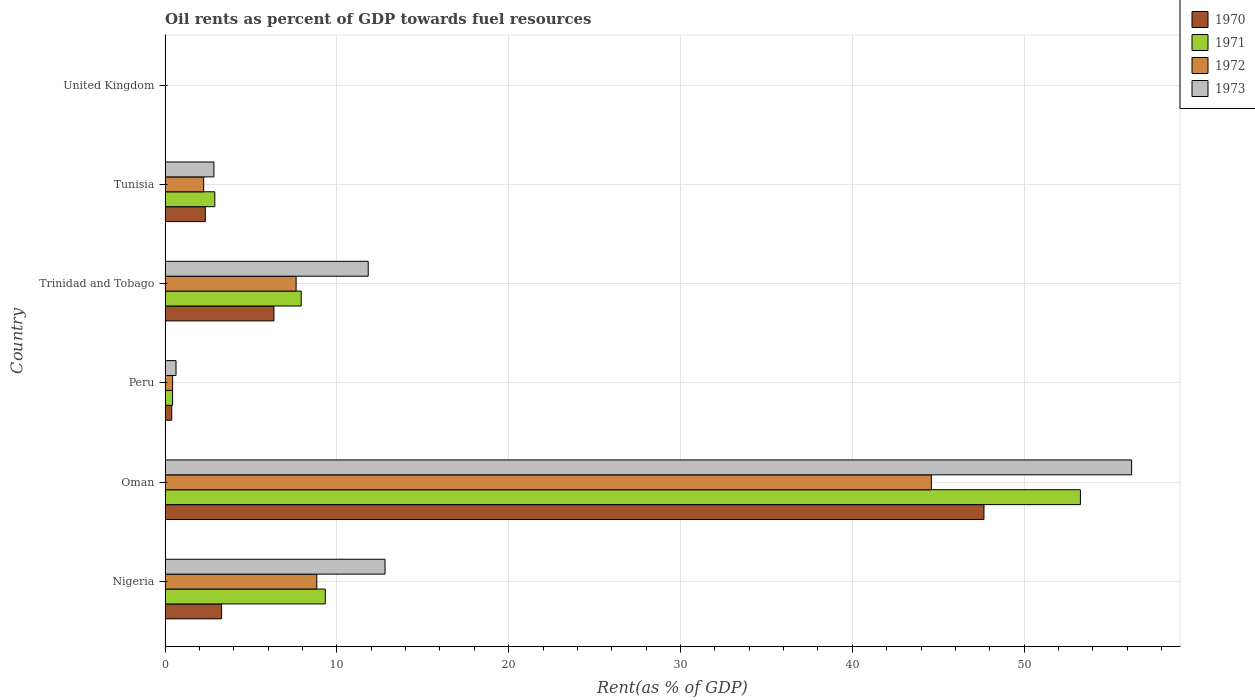How many different coloured bars are there?
Keep it short and to the point. 4. Are the number of bars per tick equal to the number of legend labels?
Offer a terse response. Yes. How many bars are there on the 3rd tick from the bottom?
Offer a terse response. 4. In how many cases, is the number of bars for a given country not equal to the number of legend labels?
Provide a short and direct response. 0. What is the oil rent in 1973 in Tunisia?
Give a very brief answer. 2.84. Across all countries, what is the maximum oil rent in 1972?
Your answer should be compact. 44.6. Across all countries, what is the minimum oil rent in 1972?
Provide a succinct answer. 0. In which country was the oil rent in 1972 maximum?
Provide a short and direct response. Oman. What is the total oil rent in 1970 in the graph?
Offer a terse response. 60.01. What is the difference between the oil rent in 1973 in Nigeria and that in Tunisia?
Provide a succinct answer. 9.96. What is the difference between the oil rent in 1972 in Oman and the oil rent in 1971 in Peru?
Give a very brief answer. 44.16. What is the average oil rent in 1972 per country?
Your response must be concise. 10.62. What is the difference between the oil rent in 1972 and oil rent in 1971 in Peru?
Give a very brief answer. 0. In how many countries, is the oil rent in 1971 greater than 48 %?
Ensure brevity in your answer.  1. What is the ratio of the oil rent in 1972 in Nigeria to that in Tunisia?
Provide a short and direct response. 3.93. Is the difference between the oil rent in 1972 in Nigeria and Peru greater than the difference between the oil rent in 1971 in Nigeria and Peru?
Provide a short and direct response. No. What is the difference between the highest and the second highest oil rent in 1970?
Give a very brief answer. 41.33. What is the difference between the highest and the lowest oil rent in 1972?
Offer a terse response. 44.6. In how many countries, is the oil rent in 1970 greater than the average oil rent in 1970 taken over all countries?
Keep it short and to the point. 1. Is the sum of the oil rent in 1972 in Trinidad and Tobago and United Kingdom greater than the maximum oil rent in 1973 across all countries?
Your answer should be very brief. No. What does the 1st bar from the bottom in Nigeria represents?
Offer a very short reply. 1970. Is it the case that in every country, the sum of the oil rent in 1972 and oil rent in 1973 is greater than the oil rent in 1970?
Keep it short and to the point. Yes. How many bars are there?
Offer a terse response. 24. Are all the bars in the graph horizontal?
Provide a short and direct response. Yes. What is the difference between two consecutive major ticks on the X-axis?
Offer a terse response. 10. Are the values on the major ticks of X-axis written in scientific E-notation?
Provide a short and direct response. No. Where does the legend appear in the graph?
Make the answer very short. Top right. How are the legend labels stacked?
Your response must be concise. Vertical. What is the title of the graph?
Your answer should be very brief. Oil rents as percent of GDP towards fuel resources. Does "2013" appear as one of the legend labels in the graph?
Ensure brevity in your answer.  No. What is the label or title of the X-axis?
Offer a very short reply. Rent(as % of GDP). What is the Rent(as % of GDP) in 1970 in Nigeria?
Make the answer very short. 3.29. What is the Rent(as % of GDP) of 1971 in Nigeria?
Give a very brief answer. 9.32. What is the Rent(as % of GDP) in 1972 in Nigeria?
Your answer should be very brief. 8.83. What is the Rent(as % of GDP) of 1973 in Nigeria?
Keep it short and to the point. 12.8. What is the Rent(as % of GDP) of 1970 in Oman?
Your answer should be very brief. 47.66. What is the Rent(as % of GDP) in 1971 in Oman?
Ensure brevity in your answer.  53.28. What is the Rent(as % of GDP) of 1972 in Oman?
Your answer should be very brief. 44.6. What is the Rent(as % of GDP) in 1973 in Oman?
Make the answer very short. 56.26. What is the Rent(as % of GDP) in 1970 in Peru?
Keep it short and to the point. 0.39. What is the Rent(as % of GDP) of 1971 in Peru?
Make the answer very short. 0.44. What is the Rent(as % of GDP) of 1972 in Peru?
Keep it short and to the point. 0.44. What is the Rent(as % of GDP) of 1973 in Peru?
Ensure brevity in your answer.  0.64. What is the Rent(as % of GDP) of 1970 in Trinidad and Tobago?
Give a very brief answer. 6.33. What is the Rent(as % of GDP) of 1971 in Trinidad and Tobago?
Provide a short and direct response. 7.92. What is the Rent(as % of GDP) in 1972 in Trinidad and Tobago?
Make the answer very short. 7.63. What is the Rent(as % of GDP) of 1973 in Trinidad and Tobago?
Give a very brief answer. 11.82. What is the Rent(as % of GDP) of 1970 in Tunisia?
Your answer should be compact. 2.34. What is the Rent(as % of GDP) in 1971 in Tunisia?
Your answer should be compact. 2.89. What is the Rent(as % of GDP) of 1972 in Tunisia?
Offer a terse response. 2.25. What is the Rent(as % of GDP) in 1973 in Tunisia?
Offer a very short reply. 2.84. What is the Rent(as % of GDP) in 1970 in United Kingdom?
Offer a terse response. 0. What is the Rent(as % of GDP) of 1971 in United Kingdom?
Keep it short and to the point. 0. What is the Rent(as % of GDP) in 1972 in United Kingdom?
Make the answer very short. 0. What is the Rent(as % of GDP) in 1973 in United Kingdom?
Make the answer very short. 0. Across all countries, what is the maximum Rent(as % of GDP) in 1970?
Ensure brevity in your answer.  47.66. Across all countries, what is the maximum Rent(as % of GDP) of 1971?
Make the answer very short. 53.28. Across all countries, what is the maximum Rent(as % of GDP) in 1972?
Your answer should be compact. 44.6. Across all countries, what is the maximum Rent(as % of GDP) of 1973?
Give a very brief answer. 56.26. Across all countries, what is the minimum Rent(as % of GDP) of 1970?
Provide a succinct answer. 0. Across all countries, what is the minimum Rent(as % of GDP) of 1971?
Your answer should be very brief. 0. Across all countries, what is the minimum Rent(as % of GDP) in 1972?
Your answer should be very brief. 0. Across all countries, what is the minimum Rent(as % of GDP) of 1973?
Your answer should be compact. 0. What is the total Rent(as % of GDP) in 1970 in the graph?
Keep it short and to the point. 60.01. What is the total Rent(as % of GDP) of 1971 in the graph?
Provide a short and direct response. 73.85. What is the total Rent(as % of GDP) in 1972 in the graph?
Provide a short and direct response. 63.74. What is the total Rent(as % of GDP) of 1973 in the graph?
Give a very brief answer. 84.36. What is the difference between the Rent(as % of GDP) in 1970 in Nigeria and that in Oman?
Your response must be concise. -44.37. What is the difference between the Rent(as % of GDP) of 1971 in Nigeria and that in Oman?
Ensure brevity in your answer.  -43.95. What is the difference between the Rent(as % of GDP) in 1972 in Nigeria and that in Oman?
Make the answer very short. -35.77. What is the difference between the Rent(as % of GDP) of 1973 in Nigeria and that in Oman?
Provide a succinct answer. -43.46. What is the difference between the Rent(as % of GDP) in 1970 in Nigeria and that in Peru?
Your answer should be compact. 2.9. What is the difference between the Rent(as % of GDP) in 1971 in Nigeria and that in Peru?
Your answer should be compact. 8.89. What is the difference between the Rent(as % of GDP) of 1972 in Nigeria and that in Peru?
Your answer should be compact. 8.39. What is the difference between the Rent(as % of GDP) of 1973 in Nigeria and that in Peru?
Your answer should be compact. 12.16. What is the difference between the Rent(as % of GDP) in 1970 in Nigeria and that in Trinidad and Tobago?
Offer a very short reply. -3.04. What is the difference between the Rent(as % of GDP) of 1971 in Nigeria and that in Trinidad and Tobago?
Your response must be concise. 1.4. What is the difference between the Rent(as % of GDP) of 1972 in Nigeria and that in Trinidad and Tobago?
Offer a terse response. 1.2. What is the difference between the Rent(as % of GDP) of 1973 in Nigeria and that in Trinidad and Tobago?
Offer a very short reply. 0.98. What is the difference between the Rent(as % of GDP) in 1970 in Nigeria and that in Tunisia?
Offer a terse response. 0.95. What is the difference between the Rent(as % of GDP) in 1971 in Nigeria and that in Tunisia?
Keep it short and to the point. 6.43. What is the difference between the Rent(as % of GDP) of 1972 in Nigeria and that in Tunisia?
Provide a succinct answer. 6.58. What is the difference between the Rent(as % of GDP) of 1973 in Nigeria and that in Tunisia?
Your answer should be compact. 9.96. What is the difference between the Rent(as % of GDP) in 1970 in Nigeria and that in United Kingdom?
Provide a succinct answer. 3.29. What is the difference between the Rent(as % of GDP) of 1971 in Nigeria and that in United Kingdom?
Provide a short and direct response. 9.32. What is the difference between the Rent(as % of GDP) in 1972 in Nigeria and that in United Kingdom?
Ensure brevity in your answer.  8.83. What is the difference between the Rent(as % of GDP) of 1973 in Nigeria and that in United Kingdom?
Provide a succinct answer. 12.8. What is the difference between the Rent(as % of GDP) of 1970 in Oman and that in Peru?
Your answer should be compact. 47.28. What is the difference between the Rent(as % of GDP) of 1971 in Oman and that in Peru?
Ensure brevity in your answer.  52.84. What is the difference between the Rent(as % of GDP) in 1972 in Oman and that in Peru?
Your answer should be compact. 44.16. What is the difference between the Rent(as % of GDP) of 1973 in Oman and that in Peru?
Your answer should be compact. 55.62. What is the difference between the Rent(as % of GDP) of 1970 in Oman and that in Trinidad and Tobago?
Your response must be concise. 41.33. What is the difference between the Rent(as % of GDP) in 1971 in Oman and that in Trinidad and Tobago?
Ensure brevity in your answer.  45.35. What is the difference between the Rent(as % of GDP) in 1972 in Oman and that in Trinidad and Tobago?
Give a very brief answer. 36.97. What is the difference between the Rent(as % of GDP) of 1973 in Oman and that in Trinidad and Tobago?
Offer a very short reply. 44.44. What is the difference between the Rent(as % of GDP) in 1970 in Oman and that in Tunisia?
Provide a succinct answer. 45.32. What is the difference between the Rent(as % of GDP) of 1971 in Oman and that in Tunisia?
Give a very brief answer. 50.38. What is the difference between the Rent(as % of GDP) of 1972 in Oman and that in Tunisia?
Keep it short and to the point. 42.36. What is the difference between the Rent(as % of GDP) in 1973 in Oman and that in Tunisia?
Your response must be concise. 53.42. What is the difference between the Rent(as % of GDP) of 1970 in Oman and that in United Kingdom?
Your answer should be very brief. 47.66. What is the difference between the Rent(as % of GDP) of 1971 in Oman and that in United Kingdom?
Keep it short and to the point. 53.28. What is the difference between the Rent(as % of GDP) of 1972 in Oman and that in United Kingdom?
Offer a very short reply. 44.6. What is the difference between the Rent(as % of GDP) in 1973 in Oman and that in United Kingdom?
Provide a succinct answer. 56.26. What is the difference between the Rent(as % of GDP) in 1970 in Peru and that in Trinidad and Tobago?
Make the answer very short. -5.95. What is the difference between the Rent(as % of GDP) in 1971 in Peru and that in Trinidad and Tobago?
Offer a terse response. -7.49. What is the difference between the Rent(as % of GDP) of 1972 in Peru and that in Trinidad and Tobago?
Your response must be concise. -7.19. What is the difference between the Rent(as % of GDP) of 1973 in Peru and that in Trinidad and Tobago?
Your answer should be compact. -11.19. What is the difference between the Rent(as % of GDP) of 1970 in Peru and that in Tunisia?
Your response must be concise. -1.95. What is the difference between the Rent(as % of GDP) in 1971 in Peru and that in Tunisia?
Offer a very short reply. -2.46. What is the difference between the Rent(as % of GDP) in 1972 in Peru and that in Tunisia?
Give a very brief answer. -1.81. What is the difference between the Rent(as % of GDP) of 1973 in Peru and that in Tunisia?
Offer a very short reply. -2.21. What is the difference between the Rent(as % of GDP) in 1970 in Peru and that in United Kingdom?
Offer a terse response. 0.38. What is the difference between the Rent(as % of GDP) of 1971 in Peru and that in United Kingdom?
Offer a terse response. 0.44. What is the difference between the Rent(as % of GDP) in 1972 in Peru and that in United Kingdom?
Your answer should be compact. 0.44. What is the difference between the Rent(as % of GDP) of 1973 in Peru and that in United Kingdom?
Offer a terse response. 0.63. What is the difference between the Rent(as % of GDP) of 1970 in Trinidad and Tobago and that in Tunisia?
Ensure brevity in your answer.  3.99. What is the difference between the Rent(as % of GDP) of 1971 in Trinidad and Tobago and that in Tunisia?
Keep it short and to the point. 5.03. What is the difference between the Rent(as % of GDP) of 1972 in Trinidad and Tobago and that in Tunisia?
Your response must be concise. 5.38. What is the difference between the Rent(as % of GDP) of 1973 in Trinidad and Tobago and that in Tunisia?
Keep it short and to the point. 8.98. What is the difference between the Rent(as % of GDP) in 1970 in Trinidad and Tobago and that in United Kingdom?
Offer a terse response. 6.33. What is the difference between the Rent(as % of GDP) of 1971 in Trinidad and Tobago and that in United Kingdom?
Your answer should be very brief. 7.92. What is the difference between the Rent(as % of GDP) of 1972 in Trinidad and Tobago and that in United Kingdom?
Make the answer very short. 7.62. What is the difference between the Rent(as % of GDP) in 1973 in Trinidad and Tobago and that in United Kingdom?
Give a very brief answer. 11.82. What is the difference between the Rent(as % of GDP) in 1970 in Tunisia and that in United Kingdom?
Keep it short and to the point. 2.34. What is the difference between the Rent(as % of GDP) of 1971 in Tunisia and that in United Kingdom?
Offer a terse response. 2.89. What is the difference between the Rent(as % of GDP) in 1972 in Tunisia and that in United Kingdom?
Your answer should be very brief. 2.24. What is the difference between the Rent(as % of GDP) in 1973 in Tunisia and that in United Kingdom?
Offer a terse response. 2.84. What is the difference between the Rent(as % of GDP) of 1970 in Nigeria and the Rent(as % of GDP) of 1971 in Oman?
Offer a terse response. -49.99. What is the difference between the Rent(as % of GDP) of 1970 in Nigeria and the Rent(as % of GDP) of 1972 in Oman?
Ensure brevity in your answer.  -41.31. What is the difference between the Rent(as % of GDP) of 1970 in Nigeria and the Rent(as % of GDP) of 1973 in Oman?
Ensure brevity in your answer.  -52.97. What is the difference between the Rent(as % of GDP) of 1971 in Nigeria and the Rent(as % of GDP) of 1972 in Oman?
Make the answer very short. -35.28. What is the difference between the Rent(as % of GDP) in 1971 in Nigeria and the Rent(as % of GDP) in 1973 in Oman?
Offer a very short reply. -46.94. What is the difference between the Rent(as % of GDP) in 1972 in Nigeria and the Rent(as % of GDP) in 1973 in Oman?
Your answer should be very brief. -47.43. What is the difference between the Rent(as % of GDP) of 1970 in Nigeria and the Rent(as % of GDP) of 1971 in Peru?
Your answer should be very brief. 2.85. What is the difference between the Rent(as % of GDP) of 1970 in Nigeria and the Rent(as % of GDP) of 1972 in Peru?
Provide a short and direct response. 2.85. What is the difference between the Rent(as % of GDP) of 1970 in Nigeria and the Rent(as % of GDP) of 1973 in Peru?
Your response must be concise. 2.65. What is the difference between the Rent(as % of GDP) of 1971 in Nigeria and the Rent(as % of GDP) of 1972 in Peru?
Offer a very short reply. 8.88. What is the difference between the Rent(as % of GDP) of 1971 in Nigeria and the Rent(as % of GDP) of 1973 in Peru?
Your response must be concise. 8.69. What is the difference between the Rent(as % of GDP) of 1972 in Nigeria and the Rent(as % of GDP) of 1973 in Peru?
Offer a terse response. 8.19. What is the difference between the Rent(as % of GDP) in 1970 in Nigeria and the Rent(as % of GDP) in 1971 in Trinidad and Tobago?
Provide a succinct answer. -4.63. What is the difference between the Rent(as % of GDP) of 1970 in Nigeria and the Rent(as % of GDP) of 1972 in Trinidad and Tobago?
Give a very brief answer. -4.34. What is the difference between the Rent(as % of GDP) in 1970 in Nigeria and the Rent(as % of GDP) in 1973 in Trinidad and Tobago?
Ensure brevity in your answer.  -8.53. What is the difference between the Rent(as % of GDP) of 1971 in Nigeria and the Rent(as % of GDP) of 1972 in Trinidad and Tobago?
Give a very brief answer. 1.7. What is the difference between the Rent(as % of GDP) of 1971 in Nigeria and the Rent(as % of GDP) of 1973 in Trinidad and Tobago?
Your response must be concise. -2.5. What is the difference between the Rent(as % of GDP) in 1972 in Nigeria and the Rent(as % of GDP) in 1973 in Trinidad and Tobago?
Keep it short and to the point. -2.99. What is the difference between the Rent(as % of GDP) in 1970 in Nigeria and the Rent(as % of GDP) in 1971 in Tunisia?
Your answer should be compact. 0.4. What is the difference between the Rent(as % of GDP) of 1970 in Nigeria and the Rent(as % of GDP) of 1972 in Tunisia?
Your response must be concise. 1.04. What is the difference between the Rent(as % of GDP) of 1970 in Nigeria and the Rent(as % of GDP) of 1973 in Tunisia?
Your answer should be compact. 0.45. What is the difference between the Rent(as % of GDP) in 1971 in Nigeria and the Rent(as % of GDP) in 1972 in Tunisia?
Your answer should be compact. 7.08. What is the difference between the Rent(as % of GDP) in 1971 in Nigeria and the Rent(as % of GDP) in 1973 in Tunisia?
Ensure brevity in your answer.  6.48. What is the difference between the Rent(as % of GDP) of 1972 in Nigeria and the Rent(as % of GDP) of 1973 in Tunisia?
Your response must be concise. 5.99. What is the difference between the Rent(as % of GDP) of 1970 in Nigeria and the Rent(as % of GDP) of 1971 in United Kingdom?
Your response must be concise. 3.29. What is the difference between the Rent(as % of GDP) of 1970 in Nigeria and the Rent(as % of GDP) of 1972 in United Kingdom?
Your response must be concise. 3.29. What is the difference between the Rent(as % of GDP) in 1970 in Nigeria and the Rent(as % of GDP) in 1973 in United Kingdom?
Keep it short and to the point. 3.29. What is the difference between the Rent(as % of GDP) in 1971 in Nigeria and the Rent(as % of GDP) in 1972 in United Kingdom?
Provide a succinct answer. 9.32. What is the difference between the Rent(as % of GDP) of 1971 in Nigeria and the Rent(as % of GDP) of 1973 in United Kingdom?
Your answer should be compact. 9.32. What is the difference between the Rent(as % of GDP) of 1972 in Nigeria and the Rent(as % of GDP) of 1973 in United Kingdom?
Your answer should be compact. 8.83. What is the difference between the Rent(as % of GDP) of 1970 in Oman and the Rent(as % of GDP) of 1971 in Peru?
Give a very brief answer. 47.23. What is the difference between the Rent(as % of GDP) of 1970 in Oman and the Rent(as % of GDP) of 1972 in Peru?
Your answer should be compact. 47.22. What is the difference between the Rent(as % of GDP) in 1970 in Oman and the Rent(as % of GDP) in 1973 in Peru?
Your answer should be compact. 47.03. What is the difference between the Rent(as % of GDP) in 1971 in Oman and the Rent(as % of GDP) in 1972 in Peru?
Offer a very short reply. 52.84. What is the difference between the Rent(as % of GDP) in 1971 in Oman and the Rent(as % of GDP) in 1973 in Peru?
Your response must be concise. 52.64. What is the difference between the Rent(as % of GDP) in 1972 in Oman and the Rent(as % of GDP) in 1973 in Peru?
Provide a succinct answer. 43.96. What is the difference between the Rent(as % of GDP) in 1970 in Oman and the Rent(as % of GDP) in 1971 in Trinidad and Tobago?
Your answer should be compact. 39.74. What is the difference between the Rent(as % of GDP) in 1970 in Oman and the Rent(as % of GDP) in 1972 in Trinidad and Tobago?
Offer a very short reply. 40.04. What is the difference between the Rent(as % of GDP) in 1970 in Oman and the Rent(as % of GDP) in 1973 in Trinidad and Tobago?
Keep it short and to the point. 35.84. What is the difference between the Rent(as % of GDP) in 1971 in Oman and the Rent(as % of GDP) in 1972 in Trinidad and Tobago?
Ensure brevity in your answer.  45.65. What is the difference between the Rent(as % of GDP) of 1971 in Oman and the Rent(as % of GDP) of 1973 in Trinidad and Tobago?
Provide a short and direct response. 41.45. What is the difference between the Rent(as % of GDP) of 1972 in Oman and the Rent(as % of GDP) of 1973 in Trinidad and Tobago?
Make the answer very short. 32.78. What is the difference between the Rent(as % of GDP) of 1970 in Oman and the Rent(as % of GDP) of 1971 in Tunisia?
Offer a terse response. 44.77. What is the difference between the Rent(as % of GDP) of 1970 in Oman and the Rent(as % of GDP) of 1972 in Tunisia?
Give a very brief answer. 45.42. What is the difference between the Rent(as % of GDP) in 1970 in Oman and the Rent(as % of GDP) in 1973 in Tunisia?
Your answer should be very brief. 44.82. What is the difference between the Rent(as % of GDP) of 1971 in Oman and the Rent(as % of GDP) of 1972 in Tunisia?
Give a very brief answer. 51.03. What is the difference between the Rent(as % of GDP) of 1971 in Oman and the Rent(as % of GDP) of 1973 in Tunisia?
Provide a short and direct response. 50.43. What is the difference between the Rent(as % of GDP) of 1972 in Oman and the Rent(as % of GDP) of 1973 in Tunisia?
Keep it short and to the point. 41.76. What is the difference between the Rent(as % of GDP) of 1970 in Oman and the Rent(as % of GDP) of 1971 in United Kingdom?
Your answer should be compact. 47.66. What is the difference between the Rent(as % of GDP) in 1970 in Oman and the Rent(as % of GDP) in 1972 in United Kingdom?
Make the answer very short. 47.66. What is the difference between the Rent(as % of GDP) in 1970 in Oman and the Rent(as % of GDP) in 1973 in United Kingdom?
Keep it short and to the point. 47.66. What is the difference between the Rent(as % of GDP) in 1971 in Oman and the Rent(as % of GDP) in 1972 in United Kingdom?
Your response must be concise. 53.28. What is the difference between the Rent(as % of GDP) in 1971 in Oman and the Rent(as % of GDP) in 1973 in United Kingdom?
Keep it short and to the point. 53.27. What is the difference between the Rent(as % of GDP) of 1972 in Oman and the Rent(as % of GDP) of 1973 in United Kingdom?
Ensure brevity in your answer.  44.6. What is the difference between the Rent(as % of GDP) of 1970 in Peru and the Rent(as % of GDP) of 1971 in Trinidad and Tobago?
Provide a succinct answer. -7.54. What is the difference between the Rent(as % of GDP) in 1970 in Peru and the Rent(as % of GDP) in 1972 in Trinidad and Tobago?
Offer a very short reply. -7.24. What is the difference between the Rent(as % of GDP) in 1970 in Peru and the Rent(as % of GDP) in 1973 in Trinidad and Tobago?
Keep it short and to the point. -11.44. What is the difference between the Rent(as % of GDP) of 1971 in Peru and the Rent(as % of GDP) of 1972 in Trinidad and Tobago?
Your response must be concise. -7.19. What is the difference between the Rent(as % of GDP) of 1971 in Peru and the Rent(as % of GDP) of 1973 in Trinidad and Tobago?
Your answer should be compact. -11.39. What is the difference between the Rent(as % of GDP) in 1972 in Peru and the Rent(as % of GDP) in 1973 in Trinidad and Tobago?
Offer a very short reply. -11.38. What is the difference between the Rent(as % of GDP) of 1970 in Peru and the Rent(as % of GDP) of 1971 in Tunisia?
Give a very brief answer. -2.51. What is the difference between the Rent(as % of GDP) of 1970 in Peru and the Rent(as % of GDP) of 1972 in Tunisia?
Provide a succinct answer. -1.86. What is the difference between the Rent(as % of GDP) of 1970 in Peru and the Rent(as % of GDP) of 1973 in Tunisia?
Offer a very short reply. -2.46. What is the difference between the Rent(as % of GDP) in 1971 in Peru and the Rent(as % of GDP) in 1972 in Tunisia?
Your answer should be very brief. -1.81. What is the difference between the Rent(as % of GDP) in 1971 in Peru and the Rent(as % of GDP) in 1973 in Tunisia?
Make the answer very short. -2.4. What is the difference between the Rent(as % of GDP) in 1972 in Peru and the Rent(as % of GDP) in 1973 in Tunisia?
Offer a very short reply. -2.4. What is the difference between the Rent(as % of GDP) in 1970 in Peru and the Rent(as % of GDP) in 1971 in United Kingdom?
Ensure brevity in your answer.  0.38. What is the difference between the Rent(as % of GDP) in 1970 in Peru and the Rent(as % of GDP) in 1972 in United Kingdom?
Your response must be concise. 0.38. What is the difference between the Rent(as % of GDP) of 1970 in Peru and the Rent(as % of GDP) of 1973 in United Kingdom?
Your answer should be compact. 0.38. What is the difference between the Rent(as % of GDP) of 1971 in Peru and the Rent(as % of GDP) of 1972 in United Kingdom?
Provide a succinct answer. 0.44. What is the difference between the Rent(as % of GDP) in 1971 in Peru and the Rent(as % of GDP) in 1973 in United Kingdom?
Make the answer very short. 0.43. What is the difference between the Rent(as % of GDP) in 1972 in Peru and the Rent(as % of GDP) in 1973 in United Kingdom?
Your answer should be compact. 0.44. What is the difference between the Rent(as % of GDP) in 1970 in Trinidad and Tobago and the Rent(as % of GDP) in 1971 in Tunisia?
Offer a very short reply. 3.44. What is the difference between the Rent(as % of GDP) of 1970 in Trinidad and Tobago and the Rent(as % of GDP) of 1972 in Tunisia?
Offer a terse response. 4.09. What is the difference between the Rent(as % of GDP) of 1970 in Trinidad and Tobago and the Rent(as % of GDP) of 1973 in Tunisia?
Keep it short and to the point. 3.49. What is the difference between the Rent(as % of GDP) of 1971 in Trinidad and Tobago and the Rent(as % of GDP) of 1972 in Tunisia?
Offer a terse response. 5.68. What is the difference between the Rent(as % of GDP) of 1971 in Trinidad and Tobago and the Rent(as % of GDP) of 1973 in Tunisia?
Offer a very short reply. 5.08. What is the difference between the Rent(as % of GDP) in 1972 in Trinidad and Tobago and the Rent(as % of GDP) in 1973 in Tunisia?
Your response must be concise. 4.78. What is the difference between the Rent(as % of GDP) in 1970 in Trinidad and Tobago and the Rent(as % of GDP) in 1971 in United Kingdom?
Your answer should be very brief. 6.33. What is the difference between the Rent(as % of GDP) of 1970 in Trinidad and Tobago and the Rent(as % of GDP) of 1972 in United Kingdom?
Your answer should be very brief. 6.33. What is the difference between the Rent(as % of GDP) of 1970 in Trinidad and Tobago and the Rent(as % of GDP) of 1973 in United Kingdom?
Offer a very short reply. 6.33. What is the difference between the Rent(as % of GDP) in 1971 in Trinidad and Tobago and the Rent(as % of GDP) in 1972 in United Kingdom?
Provide a short and direct response. 7.92. What is the difference between the Rent(as % of GDP) of 1971 in Trinidad and Tobago and the Rent(as % of GDP) of 1973 in United Kingdom?
Make the answer very short. 7.92. What is the difference between the Rent(as % of GDP) in 1972 in Trinidad and Tobago and the Rent(as % of GDP) in 1973 in United Kingdom?
Make the answer very short. 7.62. What is the difference between the Rent(as % of GDP) in 1970 in Tunisia and the Rent(as % of GDP) in 1971 in United Kingdom?
Make the answer very short. 2.34. What is the difference between the Rent(as % of GDP) of 1970 in Tunisia and the Rent(as % of GDP) of 1972 in United Kingdom?
Provide a succinct answer. 2.34. What is the difference between the Rent(as % of GDP) in 1970 in Tunisia and the Rent(as % of GDP) in 1973 in United Kingdom?
Your answer should be very brief. 2.34. What is the difference between the Rent(as % of GDP) in 1971 in Tunisia and the Rent(as % of GDP) in 1972 in United Kingdom?
Your answer should be compact. 2.89. What is the difference between the Rent(as % of GDP) of 1971 in Tunisia and the Rent(as % of GDP) of 1973 in United Kingdom?
Your answer should be very brief. 2.89. What is the difference between the Rent(as % of GDP) in 1972 in Tunisia and the Rent(as % of GDP) in 1973 in United Kingdom?
Provide a short and direct response. 2.24. What is the average Rent(as % of GDP) in 1970 per country?
Provide a succinct answer. 10. What is the average Rent(as % of GDP) in 1971 per country?
Offer a terse response. 12.31. What is the average Rent(as % of GDP) in 1972 per country?
Offer a very short reply. 10.62. What is the average Rent(as % of GDP) of 1973 per country?
Your answer should be compact. 14.06. What is the difference between the Rent(as % of GDP) in 1970 and Rent(as % of GDP) in 1971 in Nigeria?
Give a very brief answer. -6.03. What is the difference between the Rent(as % of GDP) in 1970 and Rent(as % of GDP) in 1972 in Nigeria?
Your answer should be very brief. -5.54. What is the difference between the Rent(as % of GDP) of 1970 and Rent(as % of GDP) of 1973 in Nigeria?
Offer a terse response. -9.51. What is the difference between the Rent(as % of GDP) in 1971 and Rent(as % of GDP) in 1972 in Nigeria?
Ensure brevity in your answer.  0.49. What is the difference between the Rent(as % of GDP) of 1971 and Rent(as % of GDP) of 1973 in Nigeria?
Your answer should be compact. -3.48. What is the difference between the Rent(as % of GDP) of 1972 and Rent(as % of GDP) of 1973 in Nigeria?
Provide a succinct answer. -3.97. What is the difference between the Rent(as % of GDP) of 1970 and Rent(as % of GDP) of 1971 in Oman?
Keep it short and to the point. -5.61. What is the difference between the Rent(as % of GDP) of 1970 and Rent(as % of GDP) of 1972 in Oman?
Provide a succinct answer. 3.06. What is the difference between the Rent(as % of GDP) in 1970 and Rent(as % of GDP) in 1973 in Oman?
Provide a short and direct response. -8.6. What is the difference between the Rent(as % of GDP) of 1971 and Rent(as % of GDP) of 1972 in Oman?
Offer a terse response. 8.68. What is the difference between the Rent(as % of GDP) of 1971 and Rent(as % of GDP) of 1973 in Oman?
Provide a short and direct response. -2.98. What is the difference between the Rent(as % of GDP) in 1972 and Rent(as % of GDP) in 1973 in Oman?
Provide a succinct answer. -11.66. What is the difference between the Rent(as % of GDP) in 1970 and Rent(as % of GDP) in 1971 in Peru?
Give a very brief answer. -0.05. What is the difference between the Rent(as % of GDP) in 1970 and Rent(as % of GDP) in 1972 in Peru?
Your answer should be compact. -0.05. What is the difference between the Rent(as % of GDP) of 1970 and Rent(as % of GDP) of 1973 in Peru?
Give a very brief answer. -0.25. What is the difference between the Rent(as % of GDP) of 1971 and Rent(as % of GDP) of 1972 in Peru?
Provide a succinct answer. -0. What is the difference between the Rent(as % of GDP) of 1971 and Rent(as % of GDP) of 1973 in Peru?
Keep it short and to the point. -0.2. What is the difference between the Rent(as % of GDP) in 1972 and Rent(as % of GDP) in 1973 in Peru?
Make the answer very short. -0.2. What is the difference between the Rent(as % of GDP) in 1970 and Rent(as % of GDP) in 1971 in Trinidad and Tobago?
Your answer should be very brief. -1.59. What is the difference between the Rent(as % of GDP) of 1970 and Rent(as % of GDP) of 1972 in Trinidad and Tobago?
Ensure brevity in your answer.  -1.29. What is the difference between the Rent(as % of GDP) in 1970 and Rent(as % of GDP) in 1973 in Trinidad and Tobago?
Your answer should be very brief. -5.49. What is the difference between the Rent(as % of GDP) of 1971 and Rent(as % of GDP) of 1972 in Trinidad and Tobago?
Make the answer very short. 0.3. What is the difference between the Rent(as % of GDP) in 1971 and Rent(as % of GDP) in 1973 in Trinidad and Tobago?
Give a very brief answer. -3.9. What is the difference between the Rent(as % of GDP) of 1972 and Rent(as % of GDP) of 1973 in Trinidad and Tobago?
Ensure brevity in your answer.  -4.2. What is the difference between the Rent(as % of GDP) in 1970 and Rent(as % of GDP) in 1971 in Tunisia?
Offer a terse response. -0.55. What is the difference between the Rent(as % of GDP) in 1970 and Rent(as % of GDP) in 1972 in Tunisia?
Offer a terse response. 0.1. What is the difference between the Rent(as % of GDP) of 1970 and Rent(as % of GDP) of 1973 in Tunisia?
Offer a terse response. -0.5. What is the difference between the Rent(as % of GDP) of 1971 and Rent(as % of GDP) of 1972 in Tunisia?
Ensure brevity in your answer.  0.65. What is the difference between the Rent(as % of GDP) of 1971 and Rent(as % of GDP) of 1973 in Tunisia?
Give a very brief answer. 0.05. What is the difference between the Rent(as % of GDP) in 1972 and Rent(as % of GDP) in 1973 in Tunisia?
Your response must be concise. -0.6. What is the difference between the Rent(as % of GDP) in 1970 and Rent(as % of GDP) in 1972 in United Kingdom?
Give a very brief answer. -0. What is the difference between the Rent(as % of GDP) in 1970 and Rent(as % of GDP) in 1973 in United Kingdom?
Give a very brief answer. -0. What is the difference between the Rent(as % of GDP) of 1971 and Rent(as % of GDP) of 1972 in United Kingdom?
Your answer should be compact. -0. What is the difference between the Rent(as % of GDP) in 1971 and Rent(as % of GDP) in 1973 in United Kingdom?
Offer a terse response. -0. What is the difference between the Rent(as % of GDP) of 1972 and Rent(as % of GDP) of 1973 in United Kingdom?
Your answer should be very brief. -0. What is the ratio of the Rent(as % of GDP) of 1970 in Nigeria to that in Oman?
Give a very brief answer. 0.07. What is the ratio of the Rent(as % of GDP) of 1971 in Nigeria to that in Oman?
Make the answer very short. 0.17. What is the ratio of the Rent(as % of GDP) in 1972 in Nigeria to that in Oman?
Provide a short and direct response. 0.2. What is the ratio of the Rent(as % of GDP) of 1973 in Nigeria to that in Oman?
Keep it short and to the point. 0.23. What is the ratio of the Rent(as % of GDP) of 1970 in Nigeria to that in Peru?
Your response must be concise. 8.53. What is the ratio of the Rent(as % of GDP) of 1971 in Nigeria to that in Peru?
Give a very brief answer. 21.35. What is the ratio of the Rent(as % of GDP) of 1972 in Nigeria to that in Peru?
Provide a short and direct response. 20.12. What is the ratio of the Rent(as % of GDP) in 1973 in Nigeria to that in Peru?
Provide a short and direct response. 20.13. What is the ratio of the Rent(as % of GDP) in 1970 in Nigeria to that in Trinidad and Tobago?
Your answer should be compact. 0.52. What is the ratio of the Rent(as % of GDP) in 1971 in Nigeria to that in Trinidad and Tobago?
Keep it short and to the point. 1.18. What is the ratio of the Rent(as % of GDP) in 1972 in Nigeria to that in Trinidad and Tobago?
Give a very brief answer. 1.16. What is the ratio of the Rent(as % of GDP) of 1973 in Nigeria to that in Trinidad and Tobago?
Your answer should be compact. 1.08. What is the ratio of the Rent(as % of GDP) in 1970 in Nigeria to that in Tunisia?
Your response must be concise. 1.41. What is the ratio of the Rent(as % of GDP) in 1971 in Nigeria to that in Tunisia?
Keep it short and to the point. 3.22. What is the ratio of the Rent(as % of GDP) in 1972 in Nigeria to that in Tunisia?
Offer a terse response. 3.93. What is the ratio of the Rent(as % of GDP) in 1973 in Nigeria to that in Tunisia?
Your answer should be very brief. 4.5. What is the ratio of the Rent(as % of GDP) of 1970 in Nigeria to that in United Kingdom?
Give a very brief answer. 3714.35. What is the ratio of the Rent(as % of GDP) in 1971 in Nigeria to that in United Kingdom?
Give a very brief answer. 1.32e+04. What is the ratio of the Rent(as % of GDP) in 1972 in Nigeria to that in United Kingdom?
Keep it short and to the point. 6825.07. What is the ratio of the Rent(as % of GDP) of 1973 in Nigeria to that in United Kingdom?
Ensure brevity in your answer.  5703.97. What is the ratio of the Rent(as % of GDP) of 1970 in Oman to that in Peru?
Provide a short and direct response. 123.65. What is the ratio of the Rent(as % of GDP) of 1971 in Oman to that in Peru?
Keep it short and to the point. 121.98. What is the ratio of the Rent(as % of GDP) in 1972 in Oman to that in Peru?
Ensure brevity in your answer.  101.64. What is the ratio of the Rent(as % of GDP) of 1973 in Oman to that in Peru?
Provide a short and direct response. 88.49. What is the ratio of the Rent(as % of GDP) of 1970 in Oman to that in Trinidad and Tobago?
Your response must be concise. 7.52. What is the ratio of the Rent(as % of GDP) in 1971 in Oman to that in Trinidad and Tobago?
Your response must be concise. 6.73. What is the ratio of the Rent(as % of GDP) in 1972 in Oman to that in Trinidad and Tobago?
Your response must be concise. 5.85. What is the ratio of the Rent(as % of GDP) in 1973 in Oman to that in Trinidad and Tobago?
Provide a succinct answer. 4.76. What is the ratio of the Rent(as % of GDP) in 1970 in Oman to that in Tunisia?
Your answer should be very brief. 20.37. What is the ratio of the Rent(as % of GDP) of 1971 in Oman to that in Tunisia?
Your answer should be very brief. 18.41. What is the ratio of the Rent(as % of GDP) of 1972 in Oman to that in Tunisia?
Your response must be concise. 19.87. What is the ratio of the Rent(as % of GDP) of 1973 in Oman to that in Tunisia?
Provide a short and direct response. 19.8. What is the ratio of the Rent(as % of GDP) in 1970 in Oman to that in United Kingdom?
Make the answer very short. 5.38e+04. What is the ratio of the Rent(as % of GDP) in 1971 in Oman to that in United Kingdom?
Offer a very short reply. 7.53e+04. What is the ratio of the Rent(as % of GDP) in 1972 in Oman to that in United Kingdom?
Your answer should be very brief. 3.45e+04. What is the ratio of the Rent(as % of GDP) in 1973 in Oman to that in United Kingdom?
Provide a succinct answer. 2.51e+04. What is the ratio of the Rent(as % of GDP) in 1970 in Peru to that in Trinidad and Tobago?
Offer a very short reply. 0.06. What is the ratio of the Rent(as % of GDP) in 1971 in Peru to that in Trinidad and Tobago?
Your response must be concise. 0.06. What is the ratio of the Rent(as % of GDP) in 1972 in Peru to that in Trinidad and Tobago?
Ensure brevity in your answer.  0.06. What is the ratio of the Rent(as % of GDP) of 1973 in Peru to that in Trinidad and Tobago?
Provide a short and direct response. 0.05. What is the ratio of the Rent(as % of GDP) in 1970 in Peru to that in Tunisia?
Keep it short and to the point. 0.16. What is the ratio of the Rent(as % of GDP) in 1971 in Peru to that in Tunisia?
Your response must be concise. 0.15. What is the ratio of the Rent(as % of GDP) of 1972 in Peru to that in Tunisia?
Keep it short and to the point. 0.2. What is the ratio of the Rent(as % of GDP) in 1973 in Peru to that in Tunisia?
Your answer should be very brief. 0.22. What is the ratio of the Rent(as % of GDP) of 1970 in Peru to that in United Kingdom?
Provide a succinct answer. 435.22. What is the ratio of the Rent(as % of GDP) in 1971 in Peru to that in United Kingdom?
Offer a very short reply. 617.08. What is the ratio of the Rent(as % of GDP) of 1972 in Peru to that in United Kingdom?
Make the answer very short. 339.21. What is the ratio of the Rent(as % of GDP) in 1973 in Peru to that in United Kingdom?
Your answer should be very brief. 283.34. What is the ratio of the Rent(as % of GDP) in 1970 in Trinidad and Tobago to that in Tunisia?
Your answer should be compact. 2.71. What is the ratio of the Rent(as % of GDP) of 1971 in Trinidad and Tobago to that in Tunisia?
Ensure brevity in your answer.  2.74. What is the ratio of the Rent(as % of GDP) in 1972 in Trinidad and Tobago to that in Tunisia?
Offer a terse response. 3.4. What is the ratio of the Rent(as % of GDP) in 1973 in Trinidad and Tobago to that in Tunisia?
Give a very brief answer. 4.16. What is the ratio of the Rent(as % of GDP) of 1970 in Trinidad and Tobago to that in United Kingdom?
Ensure brevity in your answer.  7151.98. What is the ratio of the Rent(as % of GDP) of 1971 in Trinidad and Tobago to that in United Kingdom?
Offer a terse response. 1.12e+04. What is the ratio of the Rent(as % of GDP) in 1972 in Trinidad and Tobago to that in United Kingdom?
Offer a terse response. 5894.4. What is the ratio of the Rent(as % of GDP) of 1973 in Trinidad and Tobago to that in United Kingdom?
Keep it short and to the point. 5268.85. What is the ratio of the Rent(as % of GDP) of 1970 in Tunisia to that in United Kingdom?
Ensure brevity in your answer.  2642.42. What is the ratio of the Rent(as % of GDP) in 1971 in Tunisia to that in United Kingdom?
Keep it short and to the point. 4088.61. What is the ratio of the Rent(as % of GDP) in 1972 in Tunisia to that in United Kingdom?
Provide a short and direct response. 1735.44. What is the ratio of the Rent(as % of GDP) in 1973 in Tunisia to that in United Kingdom?
Keep it short and to the point. 1266.39. What is the difference between the highest and the second highest Rent(as % of GDP) in 1970?
Make the answer very short. 41.33. What is the difference between the highest and the second highest Rent(as % of GDP) of 1971?
Keep it short and to the point. 43.95. What is the difference between the highest and the second highest Rent(as % of GDP) in 1972?
Make the answer very short. 35.77. What is the difference between the highest and the second highest Rent(as % of GDP) in 1973?
Provide a succinct answer. 43.46. What is the difference between the highest and the lowest Rent(as % of GDP) in 1970?
Your response must be concise. 47.66. What is the difference between the highest and the lowest Rent(as % of GDP) in 1971?
Your answer should be very brief. 53.28. What is the difference between the highest and the lowest Rent(as % of GDP) in 1972?
Offer a very short reply. 44.6. What is the difference between the highest and the lowest Rent(as % of GDP) in 1973?
Provide a short and direct response. 56.26. 